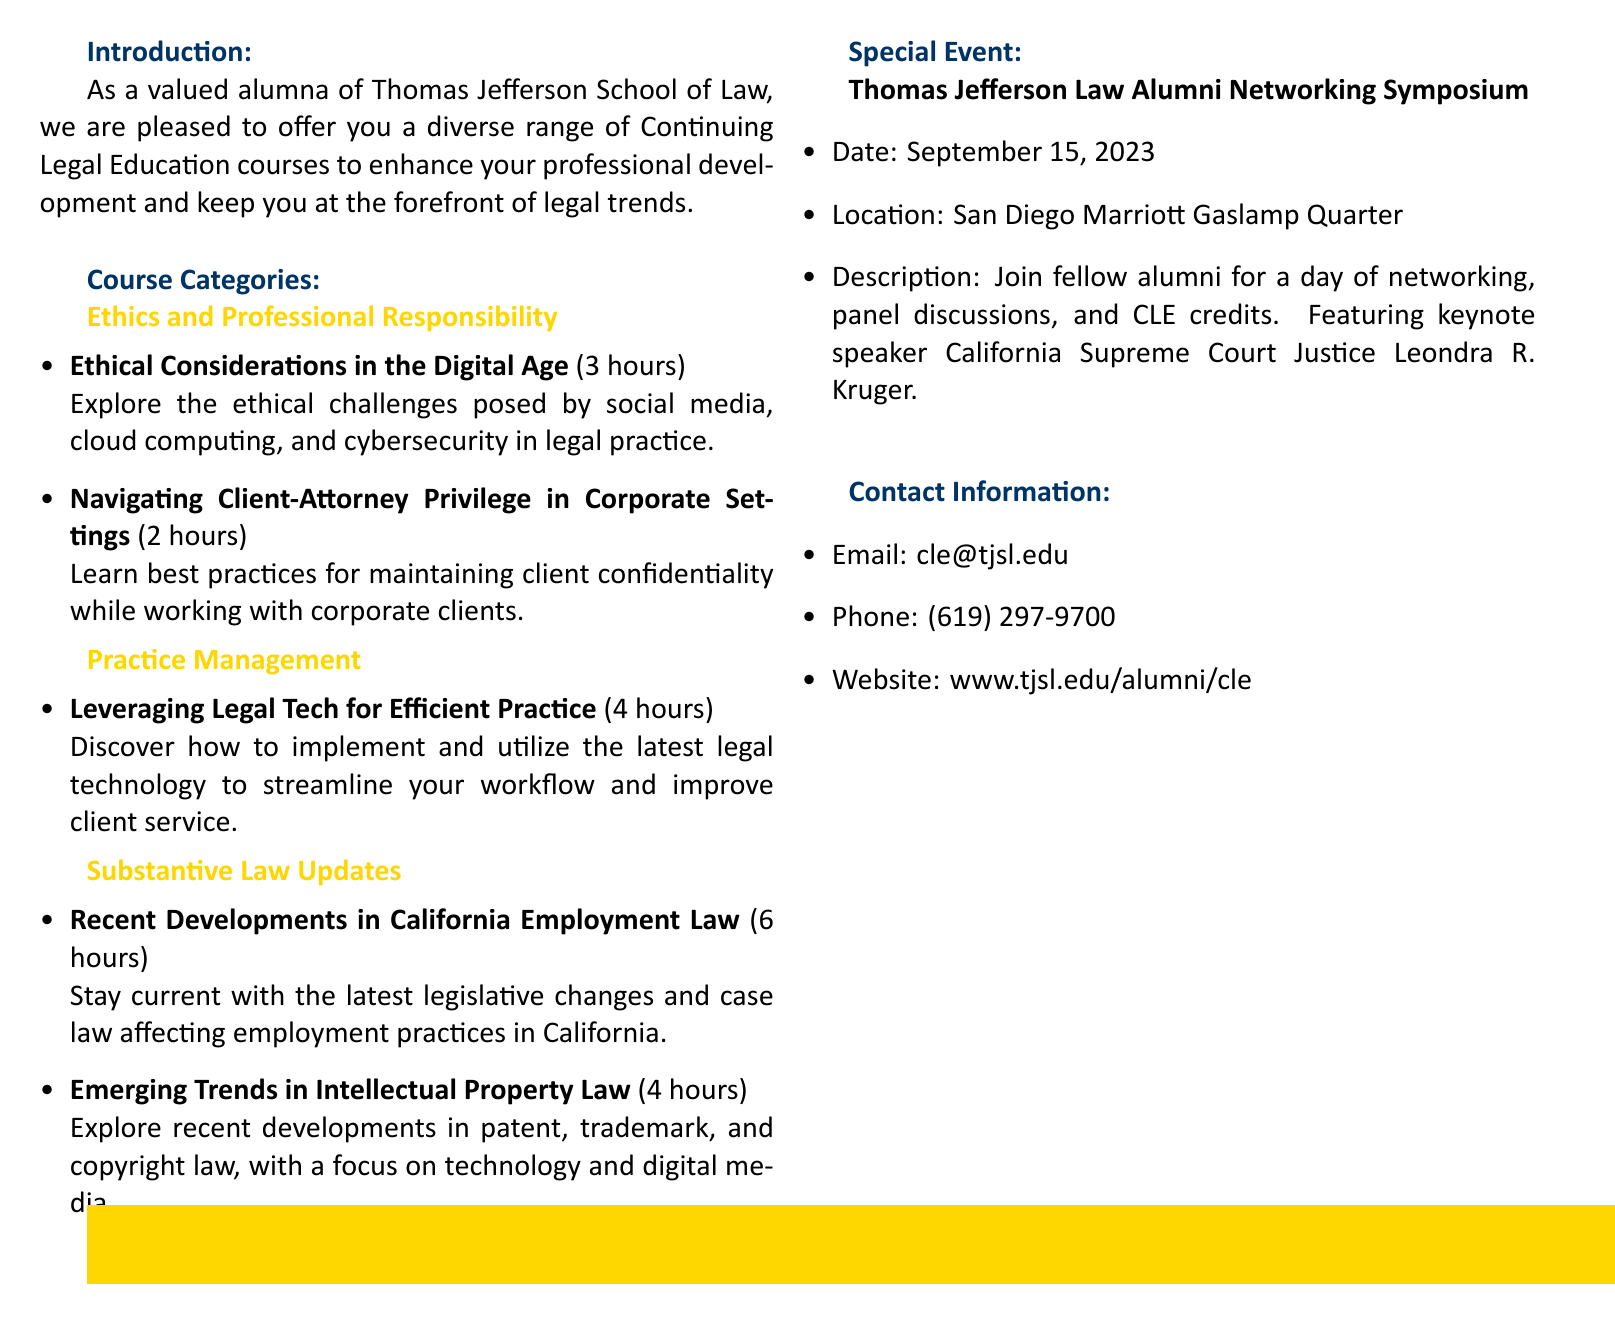What is the title of the catalog? The title is prominently displayed at the top of the document, indicating the nature of the content.
Answer: Thomas Jefferson Law Alumni CLE Catalog 2023 How many hours is the course on "Ethical Considerations in the Digital Age"? The document contains specific course details, including duration for each course.
Answer: 3 hours What is one topic covered in the "Emerging Trends in Intellectual Property Law" course? The course description provides insight into the subject matter of legal education.
Answer: Technology and digital media When is the Thomas Jefferson Law Alumni Networking Symposium? The event date is clearly specified in the document along with other relevant details.
Answer: September 15, 2023 What is the email contact for CLE inquiries? The document provides contact information, including email and phone details for support.
Answer: cle@tjsl.edu Who is the keynote speaker for the networking symposium? The document highlights important figures and their relevance to the event announced.
Answer: California Supreme Court Justice Leondra R. Kruger Which category does "Leveraging Legal Tech for Efficient Practice" belong to? Courses are organized into categories to facilitate navigation and selection.
Answer: Practice Management How many hours of CLE credit are offered for "Recent Developments in California Employment Law"? The document specifies the number of credit hours for each course.
Answer: 6 hours 